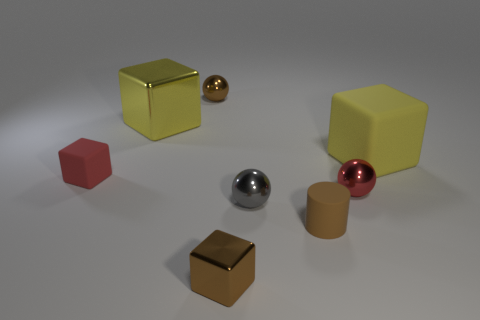Subtract all red matte cubes. How many cubes are left? 3 Add 1 red spheres. How many objects exist? 9 Subtract all red spheres. How many spheres are left? 2 Subtract all cylinders. How many objects are left? 7 Subtract all cyan balls. How many yellow cubes are left? 2 Subtract all yellow blocks. Subtract all purple matte cubes. How many objects are left? 6 Add 1 red matte blocks. How many red matte blocks are left? 2 Add 2 tiny green blocks. How many tiny green blocks exist? 2 Subtract 0 green cubes. How many objects are left? 8 Subtract 4 cubes. How many cubes are left? 0 